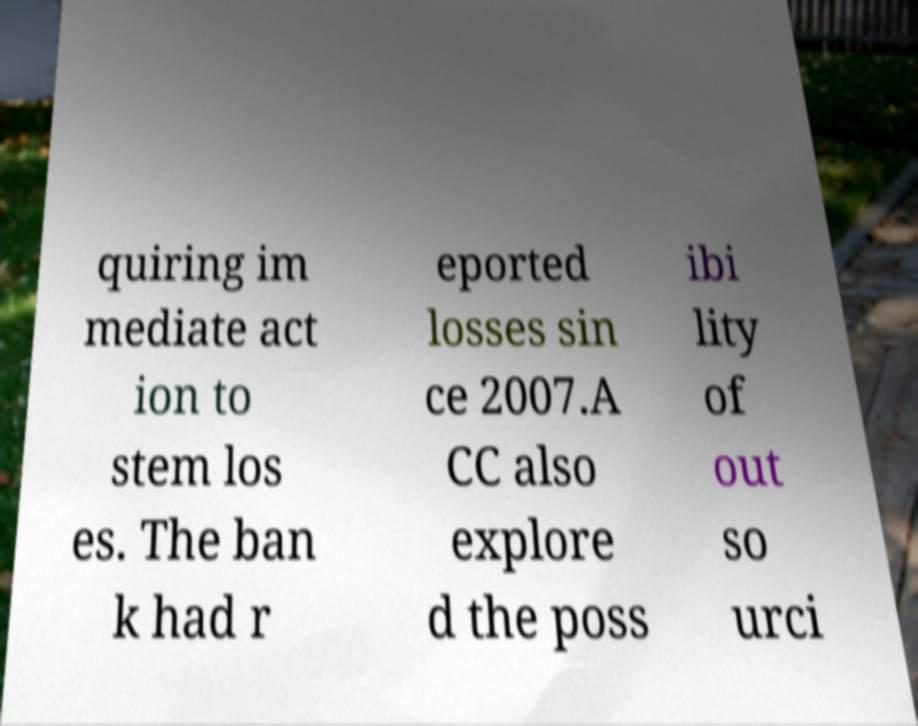Could you assist in decoding the text presented in this image and type it out clearly? quiring im mediate act ion to stem los es. The ban k had r eported losses sin ce 2007.A CC also explore d the poss ibi lity of out so urci 